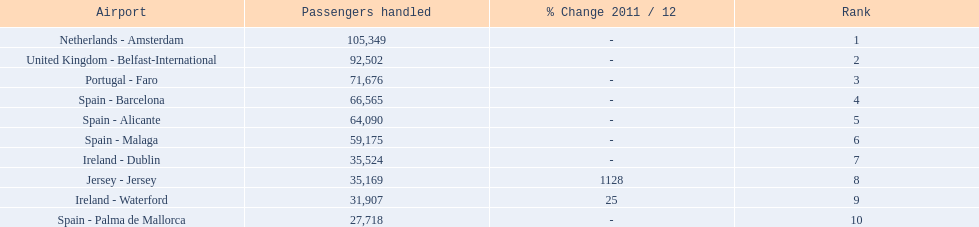Which airports are in europe? Netherlands - Amsterdam, United Kingdom - Belfast-International, Portugal - Faro, Spain - Barcelona, Spain - Alicante, Spain - Malaga, Ireland - Dublin, Ireland - Waterford, Spain - Palma de Mallorca. Which one is from portugal? Portugal - Faro. 